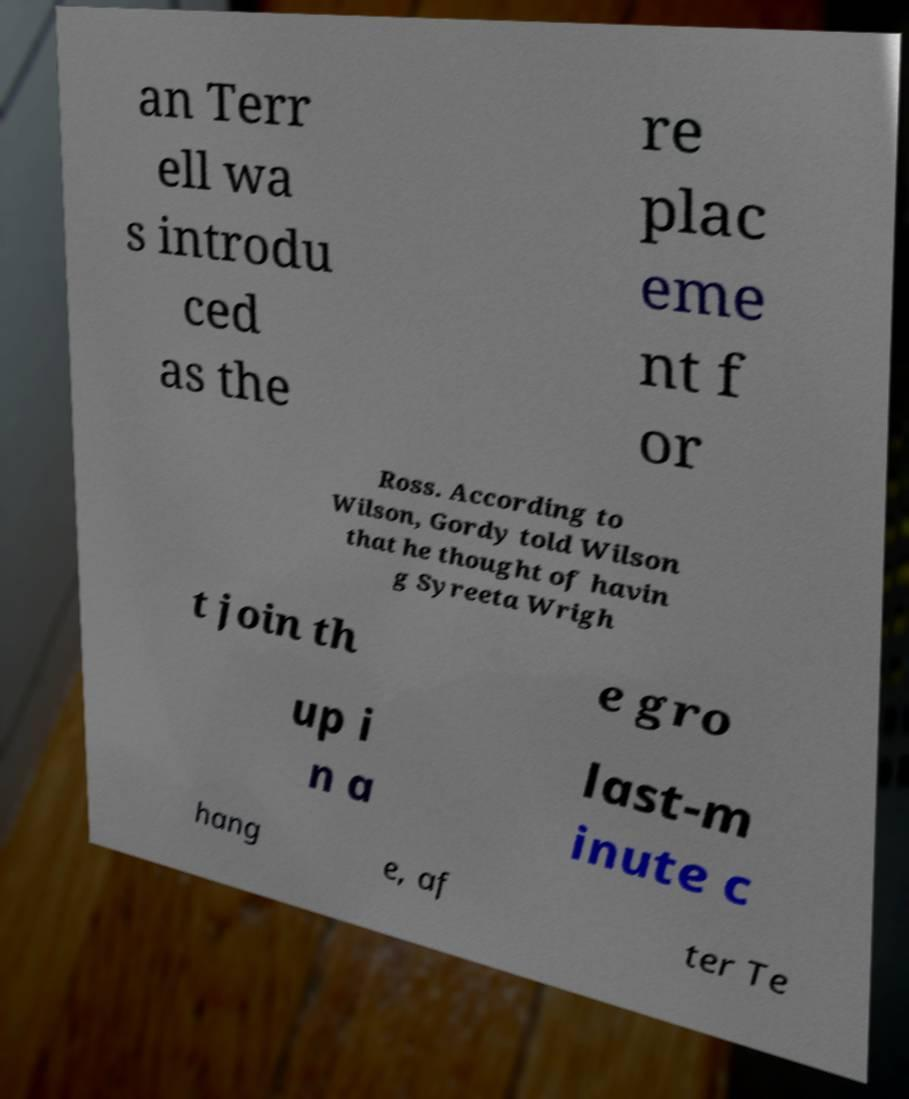Please identify and transcribe the text found in this image. an Terr ell wa s introdu ced as the re plac eme nt f or Ross. According to Wilson, Gordy told Wilson that he thought of havin g Syreeta Wrigh t join th e gro up i n a last-m inute c hang e, af ter Te 